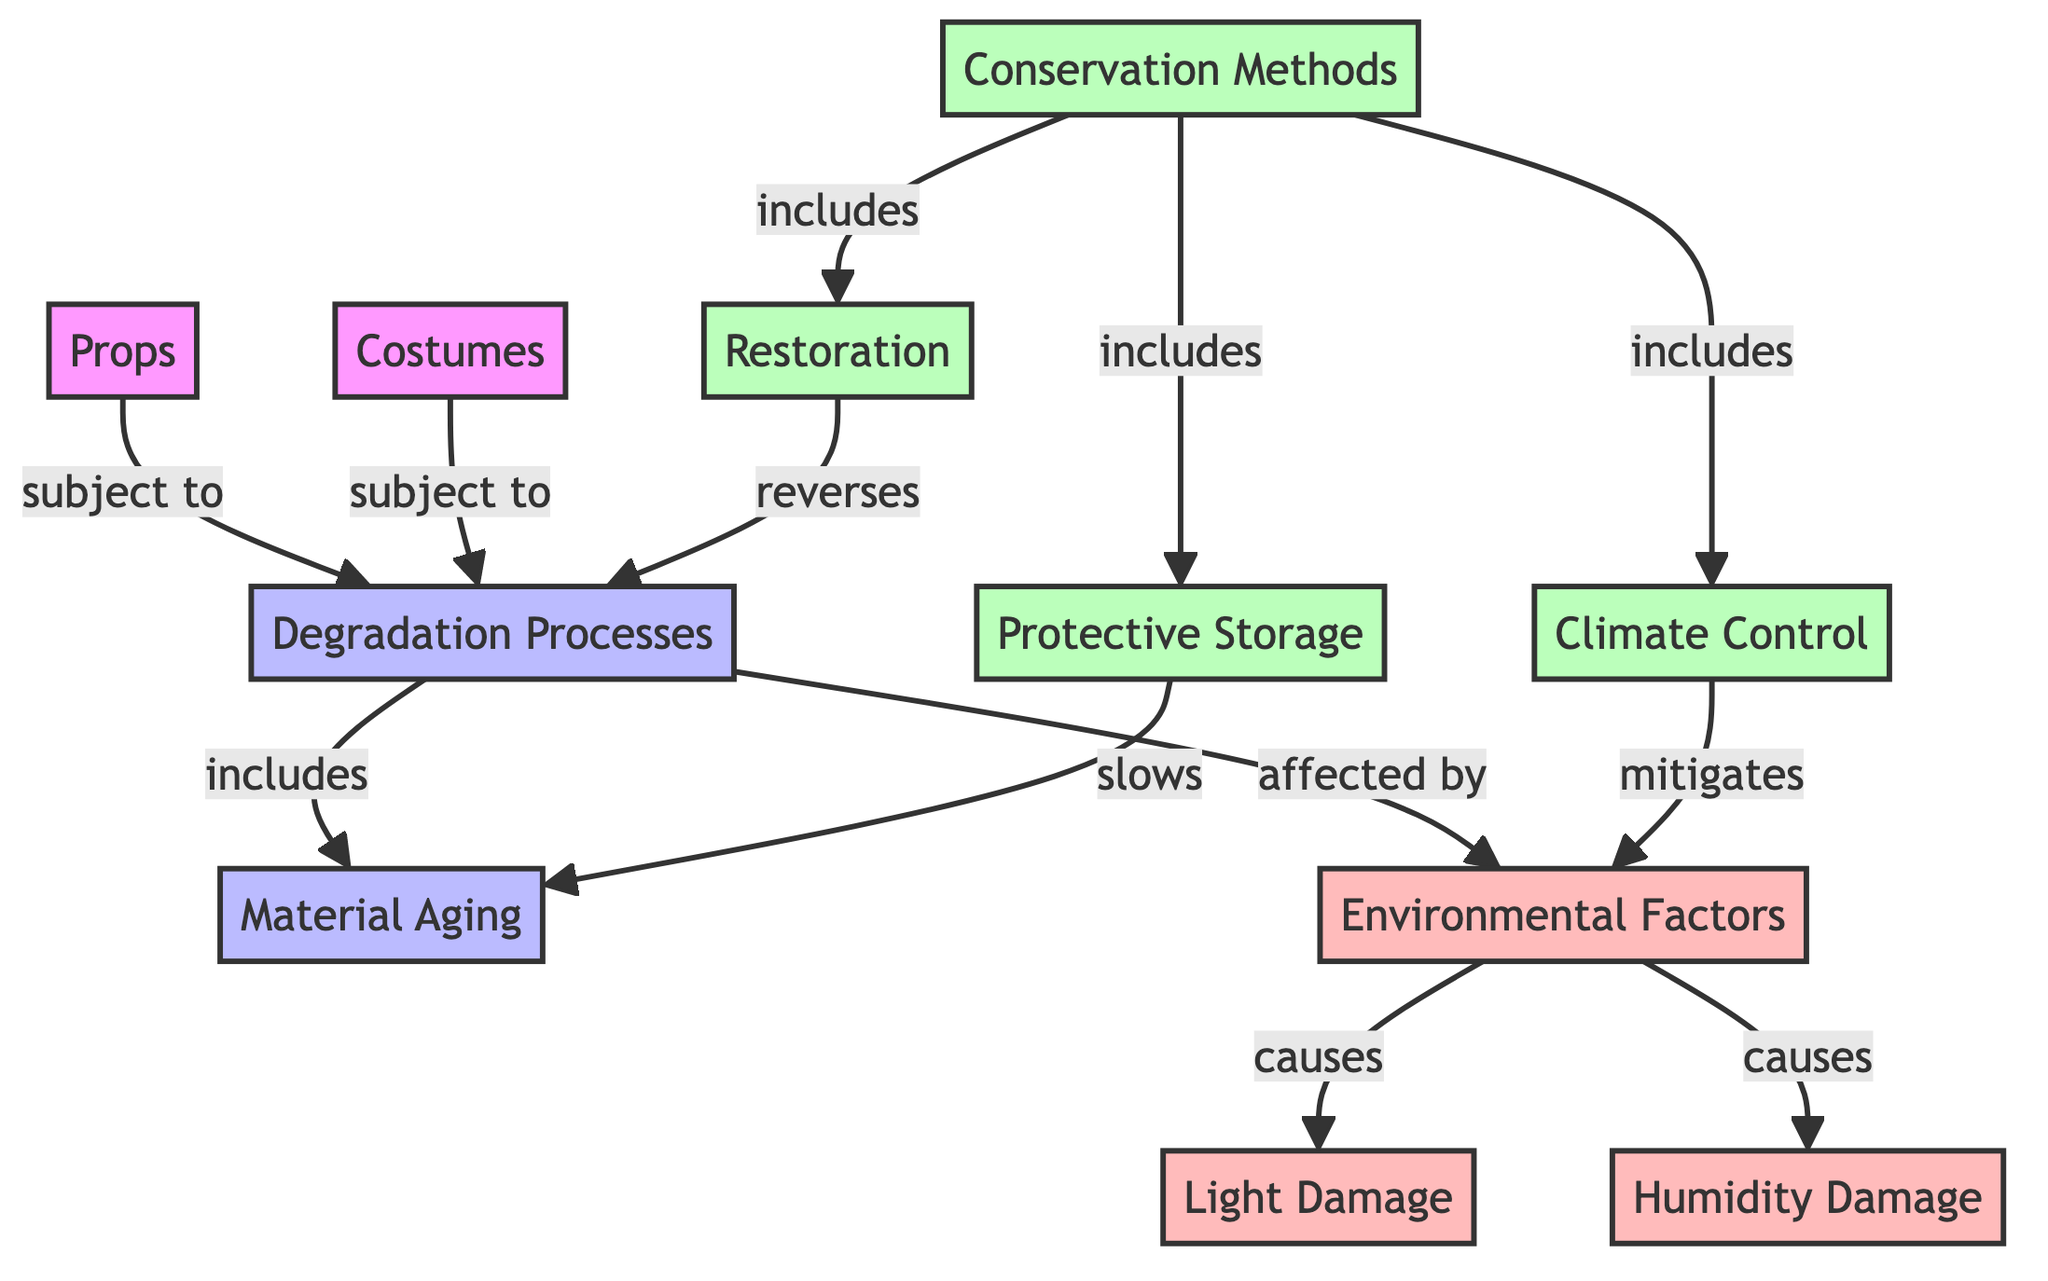What processes are props subject to? The diagram shows that props are subject to degradation processes. This can be determined by following the arrow from the "Props" node to the "Degradation Processes" node.
Answer: degradation processes How many conservation methods are listed in the diagram? Upon reviewing the conservation methods under the "Conservation Methods" node, there are three methods specified: climate, restoration, and storage. Counting these provides the answer.
Answer: 3 What environmental factors affect degradation? The diagram specifies that environmental factors cause light damage and humidity damage. Following the arrows from the "Environmental Factors" node reveals these two outcomes.
Answer: light damage and humidity damage What role does storage play in conservation? The diagram indicates that storage slows down aging. By tracing the connection from the “Storage” node toward the “Aging” node, we see this relationship clearly stated.
Answer: slows aging Which conservation method mitigates environmental factors? From the diagram, the conservation method that mitigates environmental factors is climate control. This can be found by looking at the connection leading from the "Climate Control" node to the "Environmental Factors" node, showing a direct relationship.
Answer: climate control What is the main function of restoration in conservation? The diagram notes that restoration reverses degradation. By checking the relationship shown between these two nodes, the function of restoration can be defined clearly.
Answer: reverses degradation How does aging relate to the props and costumes? The diagram indicates that both props and costumes are affected by degradation processes, which include aging as one of its components. Following the path from both nodes towards degradation clarifies this link.
Answer: affected by degradation Which node is affected by environmental factors? The diagram specifies light damage and humidity damage as outcomes caused by environmental factors. This can be established by following the arrows stemming from the environmental factors.
Answer: light damage and humidity damage What keeps props and costumes from degrading? Looking at the conservation methods, we note climate control, restoration, and storage are all ways that help keep props and costumes from degrading. This is highlighted in their respective connections within the conservation methods section of the diagram.
Answer: climate control, restoration, storage 